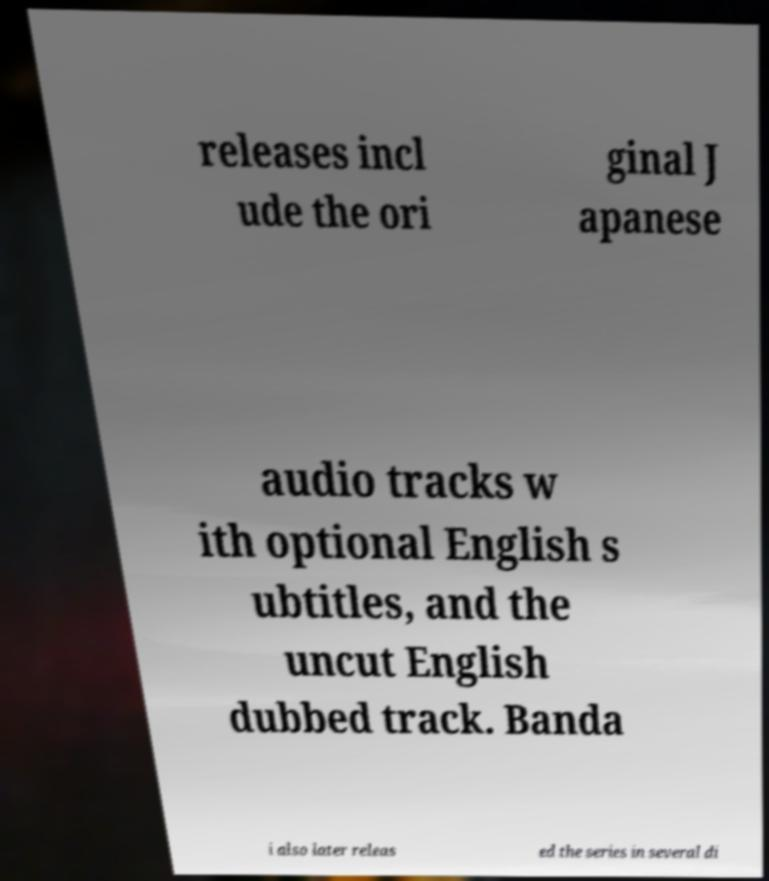Could you assist in decoding the text presented in this image and type it out clearly? releases incl ude the ori ginal J apanese audio tracks w ith optional English s ubtitles, and the uncut English dubbed track. Banda i also later releas ed the series in several di 